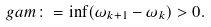Convert formula to latex. <formula><loc_0><loc_0><loc_500><loc_500>\ g a m \colon = \inf ( \omega _ { k + 1 } - \omega _ { k } ) > 0 .</formula> 